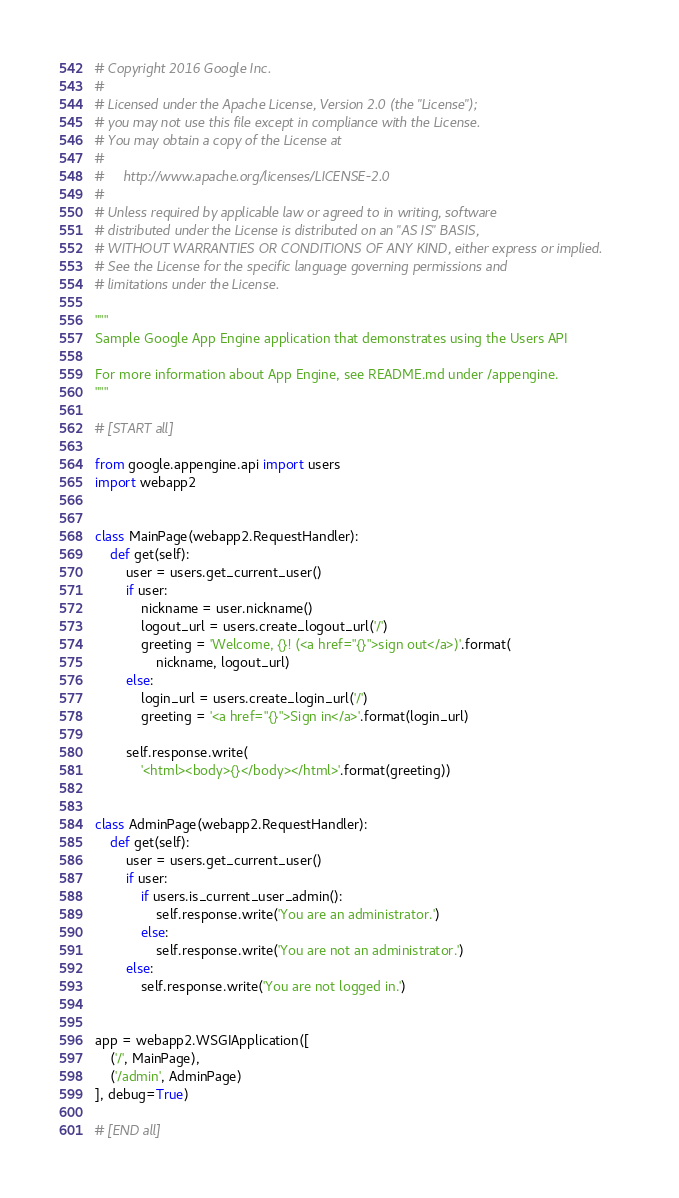Convert code to text. <code><loc_0><loc_0><loc_500><loc_500><_Python_># Copyright 2016 Google Inc.
#
# Licensed under the Apache License, Version 2.0 (the "License");
# you may not use this file except in compliance with the License.
# You may obtain a copy of the License at
#
#     http://www.apache.org/licenses/LICENSE-2.0
#
# Unless required by applicable law or agreed to in writing, software
# distributed under the License is distributed on an "AS IS" BASIS,
# WITHOUT WARRANTIES OR CONDITIONS OF ANY KIND, either express or implied.
# See the License for the specific language governing permissions and
# limitations under the License.

"""
Sample Google App Engine application that demonstrates using the Users API

For more information about App Engine, see README.md under /appengine.
"""

# [START all]

from google.appengine.api import users
import webapp2


class MainPage(webapp2.RequestHandler):
    def get(self):
        user = users.get_current_user()
        if user:
            nickname = user.nickname()
            logout_url = users.create_logout_url('/')
            greeting = 'Welcome, {}! (<a href="{}">sign out</a>)'.format(
                nickname, logout_url)
        else:
            login_url = users.create_login_url('/')
            greeting = '<a href="{}">Sign in</a>'.format(login_url)

        self.response.write(
            '<html><body>{}</body></html>'.format(greeting))


class AdminPage(webapp2.RequestHandler):
    def get(self):
        user = users.get_current_user()
        if user:
            if users.is_current_user_admin():
                self.response.write('You are an administrator.')
            else:
                self.response.write('You are not an administrator.')
        else:
            self.response.write('You are not logged in.')


app = webapp2.WSGIApplication([
    ('/', MainPage),
    ('/admin', AdminPage)
], debug=True)

# [END all]
</code> 